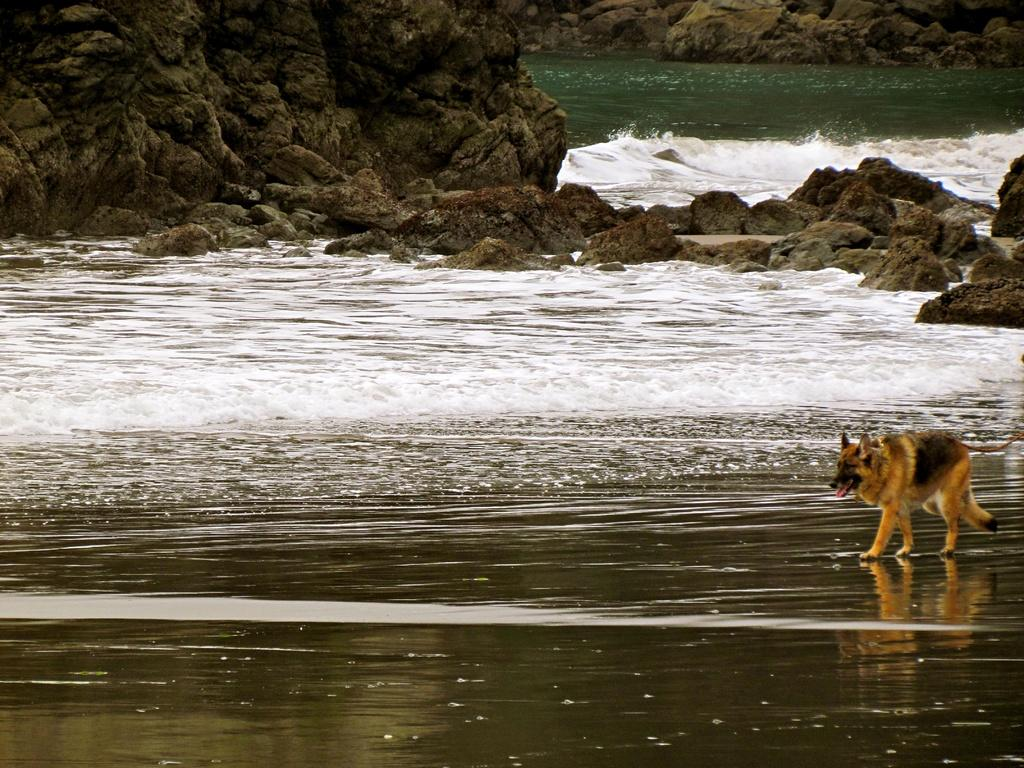What animal can be seen in the image? There is a fox in the image. What is the fox doing in the image? The fox is walking in the image. What type of terrain is visible in the image? There is water, rocks, and stones visible in the image. What type of trousers is the fox wearing in the image? Foxes do not wear trousers, so there is no information about trousers in the image. 